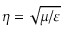<formula> <loc_0><loc_0><loc_500><loc_500>\eta = \sqrt { \mu / \varepsilon }</formula> 